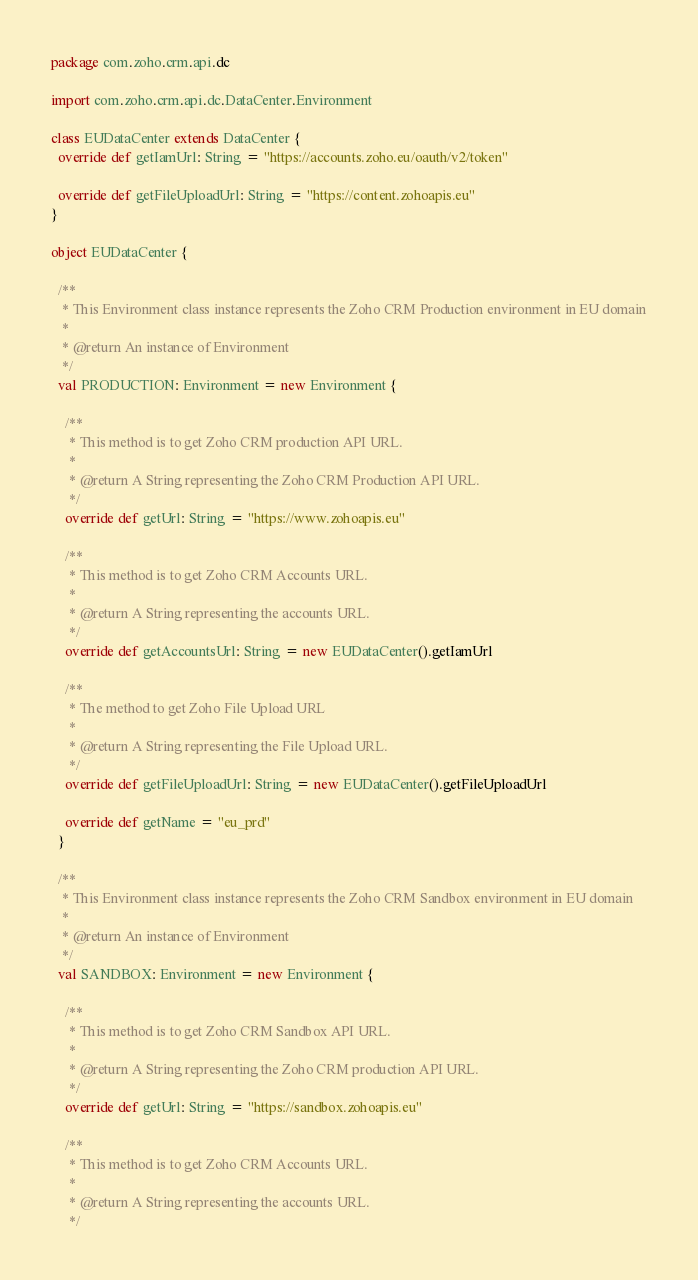Convert code to text. <code><loc_0><loc_0><loc_500><loc_500><_Scala_>package com.zoho.crm.api.dc

import com.zoho.crm.api.dc.DataCenter.Environment

class EUDataCenter extends DataCenter {
  override def getIamUrl: String = "https://accounts.zoho.eu/oauth/v2/token"

  override def getFileUploadUrl: String = "https://content.zohoapis.eu"
}

object EUDataCenter {

  /**
   * This Environment class instance represents the Zoho CRM Production environment in EU domain
   *
   * @return An instance of Environment
   */
  val PRODUCTION: Environment = new Environment {

    /**
     * This method is to get Zoho CRM production API URL.
     *
     * @return A String representing the Zoho CRM Production API URL.
     */
    override def getUrl: String = "https://www.zohoapis.eu"

    /**
     * This method is to get Zoho CRM Accounts URL.
     *
     * @return A String representing the accounts URL.
     */
    override def getAccountsUrl: String = new EUDataCenter().getIamUrl

    /**
     * The method to get Zoho File Upload URL
     *
     * @return A String representing the File Upload URL.
     */
    override def getFileUploadUrl: String = new EUDataCenter().getFileUploadUrl

    override def getName = "eu_prd"
  }

  /**
   * This Environment class instance represents the Zoho CRM Sandbox environment in EU domain
   *
   * @return An instance of Environment
   */
  val SANDBOX: Environment = new Environment {

    /**
     * This method is to get Zoho CRM Sandbox API URL.
     *
     * @return A String representing the Zoho CRM production API URL.
     */
    override def getUrl: String = "https://sandbox.zohoapis.eu"

    /**
     * This method is to get Zoho CRM Accounts URL.
     *
     * @return A String representing the accounts URL.
     */</code> 